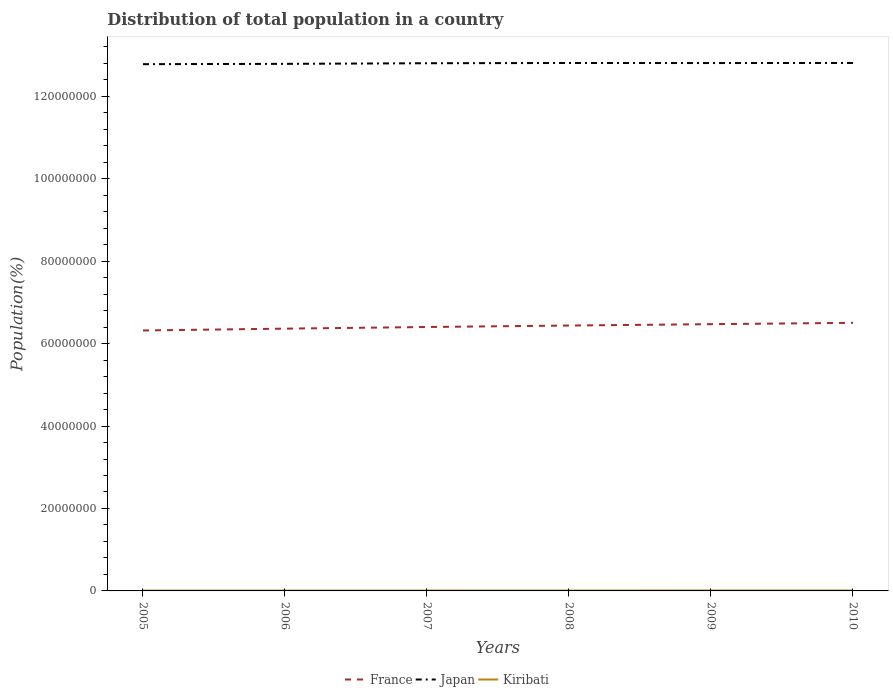Does the line corresponding to Kiribati intersect with the line corresponding to France?
Your answer should be very brief. No. Is the number of lines equal to the number of legend labels?
Provide a short and direct response. Yes. Across all years, what is the maximum population of in Kiribati?
Your answer should be compact. 9.23e+04. In which year was the population of in France maximum?
Ensure brevity in your answer.  2005. What is the total population of in Japan in the graph?
Your response must be concise. -1.93e+05. What is the difference between the highest and the second highest population of in France?
Offer a terse response. 1.85e+06. What is the difference between the highest and the lowest population of in France?
Your answer should be very brief. 3. How many years are there in the graph?
Keep it short and to the point. 6. What is the difference between two consecutive major ticks on the Y-axis?
Your answer should be compact. 2.00e+07. Does the graph contain any zero values?
Your answer should be very brief. No. Does the graph contain grids?
Keep it short and to the point. No. What is the title of the graph?
Your response must be concise. Distribution of total population in a country. Does "Malaysia" appear as one of the legend labels in the graph?
Provide a succinct answer. No. What is the label or title of the X-axis?
Ensure brevity in your answer.  Years. What is the label or title of the Y-axis?
Give a very brief answer. Population(%). What is the Population(%) of France in 2005?
Your response must be concise. 6.32e+07. What is the Population(%) of Japan in 2005?
Your answer should be compact. 1.28e+08. What is the Population(%) of Kiribati in 2005?
Provide a succinct answer. 9.23e+04. What is the Population(%) of France in 2006?
Keep it short and to the point. 6.36e+07. What is the Population(%) in Japan in 2006?
Give a very brief answer. 1.28e+08. What is the Population(%) of Kiribati in 2006?
Make the answer very short. 9.43e+04. What is the Population(%) in France in 2007?
Provide a succinct answer. 6.40e+07. What is the Population(%) of Japan in 2007?
Offer a terse response. 1.28e+08. What is the Population(%) of Kiribati in 2007?
Give a very brief answer. 9.63e+04. What is the Population(%) of France in 2008?
Make the answer very short. 6.44e+07. What is the Population(%) in Japan in 2008?
Your answer should be very brief. 1.28e+08. What is the Population(%) in Kiribati in 2008?
Make the answer very short. 9.84e+04. What is the Population(%) of France in 2009?
Provide a succinct answer. 6.47e+07. What is the Population(%) in Japan in 2009?
Provide a succinct answer. 1.28e+08. What is the Population(%) in Kiribati in 2009?
Make the answer very short. 1.01e+05. What is the Population(%) of France in 2010?
Provide a succinct answer. 6.50e+07. What is the Population(%) of Japan in 2010?
Make the answer very short. 1.28e+08. What is the Population(%) in Kiribati in 2010?
Keep it short and to the point. 1.03e+05. Across all years, what is the maximum Population(%) in France?
Ensure brevity in your answer.  6.50e+07. Across all years, what is the maximum Population(%) of Japan?
Your answer should be compact. 1.28e+08. Across all years, what is the maximum Population(%) in Kiribati?
Your answer should be very brief. 1.03e+05. Across all years, what is the minimum Population(%) in France?
Provide a short and direct response. 6.32e+07. Across all years, what is the minimum Population(%) of Japan?
Your answer should be compact. 1.28e+08. Across all years, what is the minimum Population(%) in Kiribati?
Your answer should be very brief. 9.23e+04. What is the total Population(%) in France in the graph?
Your answer should be very brief. 3.85e+08. What is the total Population(%) in Japan in the graph?
Provide a succinct answer. 7.68e+08. What is the total Population(%) of Kiribati in the graph?
Offer a terse response. 5.85e+05. What is the difference between the Population(%) in France in 2005 and that in 2006?
Make the answer very short. -4.42e+05. What is the difference between the Population(%) in Japan in 2005 and that in 2006?
Offer a terse response. -8.10e+04. What is the difference between the Population(%) in Kiribati in 2005 and that in 2006?
Provide a succinct answer. -1928. What is the difference between the Population(%) in France in 2005 and that in 2007?
Make the answer very short. -8.37e+05. What is the difference between the Population(%) of Japan in 2005 and that in 2007?
Your answer should be compact. -2.28e+05. What is the difference between the Population(%) in Kiribati in 2005 and that in 2007?
Your response must be concise. -3981. What is the difference between the Population(%) of France in 2005 and that in 2008?
Make the answer very short. -1.20e+06. What is the difference between the Population(%) in Kiribati in 2005 and that in 2008?
Provide a succinct answer. -6108. What is the difference between the Population(%) in France in 2005 and that in 2009?
Offer a very short reply. -1.53e+06. What is the difference between the Population(%) in Japan in 2005 and that in 2009?
Your response must be concise. -2.74e+05. What is the difference between the Population(%) of Kiribati in 2005 and that in 2009?
Provide a succinct answer. -8237. What is the difference between the Population(%) in France in 2005 and that in 2010?
Ensure brevity in your answer.  -1.85e+06. What is the difference between the Population(%) in Japan in 2005 and that in 2010?
Your answer should be compact. -2.97e+05. What is the difference between the Population(%) of Kiribati in 2005 and that in 2010?
Keep it short and to the point. -1.03e+04. What is the difference between the Population(%) in France in 2006 and that in 2007?
Offer a very short reply. -3.95e+05. What is the difference between the Population(%) in Japan in 2006 and that in 2007?
Keep it short and to the point. -1.47e+05. What is the difference between the Population(%) of Kiribati in 2006 and that in 2007?
Provide a short and direct response. -2053. What is the difference between the Population(%) of France in 2006 and that in 2008?
Ensure brevity in your answer.  -7.54e+05. What is the difference between the Population(%) of Japan in 2006 and that in 2008?
Offer a terse response. -2.09e+05. What is the difference between the Population(%) in Kiribati in 2006 and that in 2008?
Ensure brevity in your answer.  -4180. What is the difference between the Population(%) in France in 2006 and that in 2009?
Offer a very short reply. -1.09e+06. What is the difference between the Population(%) of Japan in 2006 and that in 2009?
Ensure brevity in your answer.  -1.93e+05. What is the difference between the Population(%) of Kiribati in 2006 and that in 2009?
Make the answer very short. -6309. What is the difference between the Population(%) of France in 2006 and that in 2010?
Give a very brief answer. -1.41e+06. What is the difference between the Population(%) in Japan in 2006 and that in 2010?
Provide a short and direct response. -2.16e+05. What is the difference between the Population(%) in Kiribati in 2006 and that in 2010?
Give a very brief answer. -8391. What is the difference between the Population(%) of France in 2007 and that in 2008?
Offer a very short reply. -3.59e+05. What is the difference between the Population(%) in Japan in 2007 and that in 2008?
Keep it short and to the point. -6.20e+04. What is the difference between the Population(%) in Kiribati in 2007 and that in 2008?
Offer a terse response. -2127. What is the difference between the Population(%) of France in 2007 and that in 2009?
Keep it short and to the point. -6.91e+05. What is the difference between the Population(%) of Japan in 2007 and that in 2009?
Your answer should be very brief. -4.60e+04. What is the difference between the Population(%) in Kiribati in 2007 and that in 2009?
Make the answer very short. -4256. What is the difference between the Population(%) of France in 2007 and that in 2010?
Ensure brevity in your answer.  -1.01e+06. What is the difference between the Population(%) of Japan in 2007 and that in 2010?
Your answer should be very brief. -6.90e+04. What is the difference between the Population(%) in Kiribati in 2007 and that in 2010?
Give a very brief answer. -6338. What is the difference between the Population(%) of France in 2008 and that in 2009?
Offer a very short reply. -3.32e+05. What is the difference between the Population(%) in Japan in 2008 and that in 2009?
Give a very brief answer. 1.60e+04. What is the difference between the Population(%) in Kiribati in 2008 and that in 2009?
Your answer should be very brief. -2129. What is the difference between the Population(%) in France in 2008 and that in 2010?
Give a very brief answer. -6.53e+05. What is the difference between the Population(%) of Japan in 2008 and that in 2010?
Ensure brevity in your answer.  -7000. What is the difference between the Population(%) in Kiribati in 2008 and that in 2010?
Your answer should be compact. -4211. What is the difference between the Population(%) in France in 2009 and that in 2010?
Keep it short and to the point. -3.20e+05. What is the difference between the Population(%) in Japan in 2009 and that in 2010?
Offer a terse response. -2.30e+04. What is the difference between the Population(%) in Kiribati in 2009 and that in 2010?
Keep it short and to the point. -2082. What is the difference between the Population(%) of France in 2005 and the Population(%) of Japan in 2006?
Provide a short and direct response. -6.47e+07. What is the difference between the Population(%) in France in 2005 and the Population(%) in Kiribati in 2006?
Offer a terse response. 6.31e+07. What is the difference between the Population(%) in Japan in 2005 and the Population(%) in Kiribati in 2006?
Your answer should be very brief. 1.28e+08. What is the difference between the Population(%) of France in 2005 and the Population(%) of Japan in 2007?
Ensure brevity in your answer.  -6.48e+07. What is the difference between the Population(%) in France in 2005 and the Population(%) in Kiribati in 2007?
Provide a succinct answer. 6.31e+07. What is the difference between the Population(%) of Japan in 2005 and the Population(%) of Kiribati in 2007?
Offer a terse response. 1.28e+08. What is the difference between the Population(%) of France in 2005 and the Population(%) of Japan in 2008?
Provide a succinct answer. -6.49e+07. What is the difference between the Population(%) in France in 2005 and the Population(%) in Kiribati in 2008?
Provide a short and direct response. 6.31e+07. What is the difference between the Population(%) in Japan in 2005 and the Population(%) in Kiribati in 2008?
Ensure brevity in your answer.  1.28e+08. What is the difference between the Population(%) of France in 2005 and the Population(%) of Japan in 2009?
Offer a terse response. -6.49e+07. What is the difference between the Population(%) in France in 2005 and the Population(%) in Kiribati in 2009?
Your answer should be compact. 6.31e+07. What is the difference between the Population(%) in Japan in 2005 and the Population(%) in Kiribati in 2009?
Offer a terse response. 1.28e+08. What is the difference between the Population(%) of France in 2005 and the Population(%) of Japan in 2010?
Make the answer very short. -6.49e+07. What is the difference between the Population(%) in France in 2005 and the Population(%) in Kiribati in 2010?
Your answer should be very brief. 6.31e+07. What is the difference between the Population(%) of Japan in 2005 and the Population(%) of Kiribati in 2010?
Offer a terse response. 1.28e+08. What is the difference between the Population(%) of France in 2006 and the Population(%) of Japan in 2007?
Make the answer very short. -6.44e+07. What is the difference between the Population(%) in France in 2006 and the Population(%) in Kiribati in 2007?
Offer a terse response. 6.35e+07. What is the difference between the Population(%) in Japan in 2006 and the Population(%) in Kiribati in 2007?
Your response must be concise. 1.28e+08. What is the difference between the Population(%) of France in 2006 and the Population(%) of Japan in 2008?
Offer a terse response. -6.44e+07. What is the difference between the Population(%) in France in 2006 and the Population(%) in Kiribati in 2008?
Provide a short and direct response. 6.35e+07. What is the difference between the Population(%) in Japan in 2006 and the Population(%) in Kiribati in 2008?
Your response must be concise. 1.28e+08. What is the difference between the Population(%) in France in 2006 and the Population(%) in Japan in 2009?
Ensure brevity in your answer.  -6.44e+07. What is the difference between the Population(%) in France in 2006 and the Population(%) in Kiribati in 2009?
Your answer should be very brief. 6.35e+07. What is the difference between the Population(%) of Japan in 2006 and the Population(%) of Kiribati in 2009?
Offer a very short reply. 1.28e+08. What is the difference between the Population(%) in France in 2006 and the Population(%) in Japan in 2010?
Provide a short and direct response. -6.44e+07. What is the difference between the Population(%) in France in 2006 and the Population(%) in Kiribati in 2010?
Your answer should be compact. 6.35e+07. What is the difference between the Population(%) of Japan in 2006 and the Population(%) of Kiribati in 2010?
Provide a short and direct response. 1.28e+08. What is the difference between the Population(%) in France in 2007 and the Population(%) in Japan in 2008?
Provide a short and direct response. -6.40e+07. What is the difference between the Population(%) of France in 2007 and the Population(%) of Kiribati in 2008?
Provide a succinct answer. 6.39e+07. What is the difference between the Population(%) of Japan in 2007 and the Population(%) of Kiribati in 2008?
Your answer should be very brief. 1.28e+08. What is the difference between the Population(%) in France in 2007 and the Population(%) in Japan in 2009?
Make the answer very short. -6.40e+07. What is the difference between the Population(%) in France in 2007 and the Population(%) in Kiribati in 2009?
Keep it short and to the point. 6.39e+07. What is the difference between the Population(%) of Japan in 2007 and the Population(%) of Kiribati in 2009?
Ensure brevity in your answer.  1.28e+08. What is the difference between the Population(%) in France in 2007 and the Population(%) in Japan in 2010?
Give a very brief answer. -6.41e+07. What is the difference between the Population(%) in France in 2007 and the Population(%) in Kiribati in 2010?
Provide a succinct answer. 6.39e+07. What is the difference between the Population(%) of Japan in 2007 and the Population(%) of Kiribati in 2010?
Provide a short and direct response. 1.28e+08. What is the difference between the Population(%) in France in 2008 and the Population(%) in Japan in 2009?
Your answer should be compact. -6.37e+07. What is the difference between the Population(%) of France in 2008 and the Population(%) of Kiribati in 2009?
Provide a short and direct response. 6.43e+07. What is the difference between the Population(%) of Japan in 2008 and the Population(%) of Kiribati in 2009?
Give a very brief answer. 1.28e+08. What is the difference between the Population(%) of France in 2008 and the Population(%) of Japan in 2010?
Provide a short and direct response. -6.37e+07. What is the difference between the Population(%) in France in 2008 and the Population(%) in Kiribati in 2010?
Provide a short and direct response. 6.43e+07. What is the difference between the Population(%) in Japan in 2008 and the Population(%) in Kiribati in 2010?
Give a very brief answer. 1.28e+08. What is the difference between the Population(%) of France in 2009 and the Population(%) of Japan in 2010?
Make the answer very short. -6.34e+07. What is the difference between the Population(%) in France in 2009 and the Population(%) in Kiribati in 2010?
Ensure brevity in your answer.  6.46e+07. What is the difference between the Population(%) of Japan in 2009 and the Population(%) of Kiribati in 2010?
Your answer should be compact. 1.28e+08. What is the average Population(%) of France per year?
Ensure brevity in your answer.  6.42e+07. What is the average Population(%) in Japan per year?
Offer a very short reply. 1.28e+08. What is the average Population(%) of Kiribati per year?
Provide a succinct answer. 9.74e+04. In the year 2005, what is the difference between the Population(%) in France and Population(%) in Japan?
Give a very brief answer. -6.46e+07. In the year 2005, what is the difference between the Population(%) in France and Population(%) in Kiribati?
Your response must be concise. 6.31e+07. In the year 2005, what is the difference between the Population(%) in Japan and Population(%) in Kiribati?
Offer a very short reply. 1.28e+08. In the year 2006, what is the difference between the Population(%) in France and Population(%) in Japan?
Offer a very short reply. -6.42e+07. In the year 2006, what is the difference between the Population(%) of France and Population(%) of Kiribati?
Offer a terse response. 6.35e+07. In the year 2006, what is the difference between the Population(%) of Japan and Population(%) of Kiribati?
Your answer should be very brief. 1.28e+08. In the year 2007, what is the difference between the Population(%) of France and Population(%) of Japan?
Make the answer very short. -6.40e+07. In the year 2007, what is the difference between the Population(%) of France and Population(%) of Kiribati?
Ensure brevity in your answer.  6.39e+07. In the year 2007, what is the difference between the Population(%) in Japan and Population(%) in Kiribati?
Your answer should be very brief. 1.28e+08. In the year 2008, what is the difference between the Population(%) in France and Population(%) in Japan?
Provide a succinct answer. -6.37e+07. In the year 2008, what is the difference between the Population(%) of France and Population(%) of Kiribati?
Give a very brief answer. 6.43e+07. In the year 2008, what is the difference between the Population(%) of Japan and Population(%) of Kiribati?
Your answer should be very brief. 1.28e+08. In the year 2009, what is the difference between the Population(%) in France and Population(%) in Japan?
Your answer should be compact. -6.33e+07. In the year 2009, what is the difference between the Population(%) of France and Population(%) of Kiribati?
Offer a terse response. 6.46e+07. In the year 2009, what is the difference between the Population(%) of Japan and Population(%) of Kiribati?
Your answer should be very brief. 1.28e+08. In the year 2010, what is the difference between the Population(%) in France and Population(%) in Japan?
Offer a terse response. -6.30e+07. In the year 2010, what is the difference between the Population(%) in France and Population(%) in Kiribati?
Offer a terse response. 6.49e+07. In the year 2010, what is the difference between the Population(%) of Japan and Population(%) of Kiribati?
Make the answer very short. 1.28e+08. What is the ratio of the Population(%) in France in 2005 to that in 2006?
Give a very brief answer. 0.99. What is the ratio of the Population(%) in Kiribati in 2005 to that in 2006?
Your response must be concise. 0.98. What is the ratio of the Population(%) in France in 2005 to that in 2007?
Offer a very short reply. 0.99. What is the ratio of the Population(%) of Kiribati in 2005 to that in 2007?
Ensure brevity in your answer.  0.96. What is the ratio of the Population(%) in France in 2005 to that in 2008?
Make the answer very short. 0.98. What is the ratio of the Population(%) of Japan in 2005 to that in 2008?
Ensure brevity in your answer.  1. What is the ratio of the Population(%) in Kiribati in 2005 to that in 2008?
Offer a terse response. 0.94. What is the ratio of the Population(%) of France in 2005 to that in 2009?
Your response must be concise. 0.98. What is the ratio of the Population(%) of Japan in 2005 to that in 2009?
Provide a succinct answer. 1. What is the ratio of the Population(%) in Kiribati in 2005 to that in 2009?
Offer a very short reply. 0.92. What is the ratio of the Population(%) of France in 2005 to that in 2010?
Keep it short and to the point. 0.97. What is the ratio of the Population(%) in Japan in 2005 to that in 2010?
Keep it short and to the point. 1. What is the ratio of the Population(%) of Kiribati in 2005 to that in 2010?
Your response must be concise. 0.9. What is the ratio of the Population(%) of Japan in 2006 to that in 2007?
Offer a terse response. 1. What is the ratio of the Population(%) in Kiribati in 2006 to that in 2007?
Offer a very short reply. 0.98. What is the ratio of the Population(%) of France in 2006 to that in 2008?
Your answer should be compact. 0.99. What is the ratio of the Population(%) of Japan in 2006 to that in 2008?
Make the answer very short. 1. What is the ratio of the Population(%) of Kiribati in 2006 to that in 2008?
Make the answer very short. 0.96. What is the ratio of the Population(%) of France in 2006 to that in 2009?
Your answer should be compact. 0.98. What is the ratio of the Population(%) in Kiribati in 2006 to that in 2009?
Keep it short and to the point. 0.94. What is the ratio of the Population(%) in France in 2006 to that in 2010?
Provide a succinct answer. 0.98. What is the ratio of the Population(%) in Japan in 2006 to that in 2010?
Your response must be concise. 1. What is the ratio of the Population(%) in Kiribati in 2006 to that in 2010?
Ensure brevity in your answer.  0.92. What is the ratio of the Population(%) in Kiribati in 2007 to that in 2008?
Ensure brevity in your answer.  0.98. What is the ratio of the Population(%) of France in 2007 to that in 2009?
Provide a short and direct response. 0.99. What is the ratio of the Population(%) of Kiribati in 2007 to that in 2009?
Offer a very short reply. 0.96. What is the ratio of the Population(%) of France in 2007 to that in 2010?
Give a very brief answer. 0.98. What is the ratio of the Population(%) of Kiribati in 2007 to that in 2010?
Offer a very short reply. 0.94. What is the ratio of the Population(%) of Japan in 2008 to that in 2009?
Give a very brief answer. 1. What is the ratio of the Population(%) in Kiribati in 2008 to that in 2009?
Provide a succinct answer. 0.98. What is the ratio of the Population(%) in France in 2008 to that in 2010?
Provide a succinct answer. 0.99. What is the ratio of the Population(%) of Kiribati in 2008 to that in 2010?
Give a very brief answer. 0.96. What is the ratio of the Population(%) in France in 2009 to that in 2010?
Give a very brief answer. 1. What is the ratio of the Population(%) of Japan in 2009 to that in 2010?
Offer a very short reply. 1. What is the ratio of the Population(%) of Kiribati in 2009 to that in 2010?
Provide a short and direct response. 0.98. What is the difference between the highest and the second highest Population(%) in France?
Your response must be concise. 3.20e+05. What is the difference between the highest and the second highest Population(%) of Japan?
Offer a very short reply. 7000. What is the difference between the highest and the second highest Population(%) in Kiribati?
Keep it short and to the point. 2082. What is the difference between the highest and the lowest Population(%) of France?
Offer a very short reply. 1.85e+06. What is the difference between the highest and the lowest Population(%) of Japan?
Give a very brief answer. 2.97e+05. What is the difference between the highest and the lowest Population(%) of Kiribati?
Make the answer very short. 1.03e+04. 